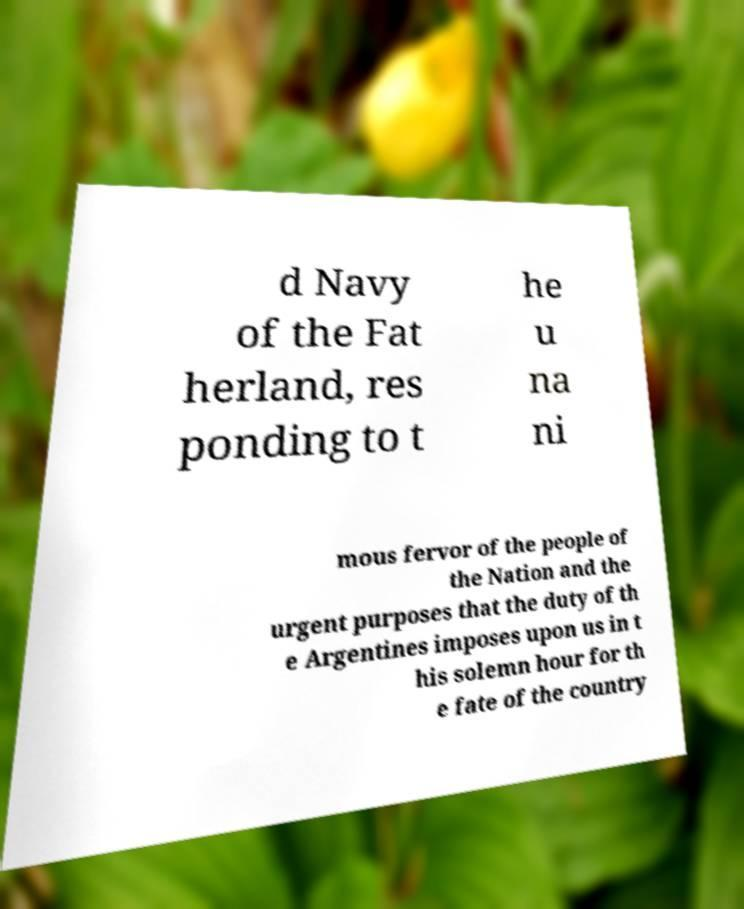I need the written content from this picture converted into text. Can you do that? d Navy of the Fat herland, res ponding to t he u na ni mous fervor of the people of the Nation and the urgent purposes that the duty of th e Argentines imposes upon us in t his solemn hour for th e fate of the country 